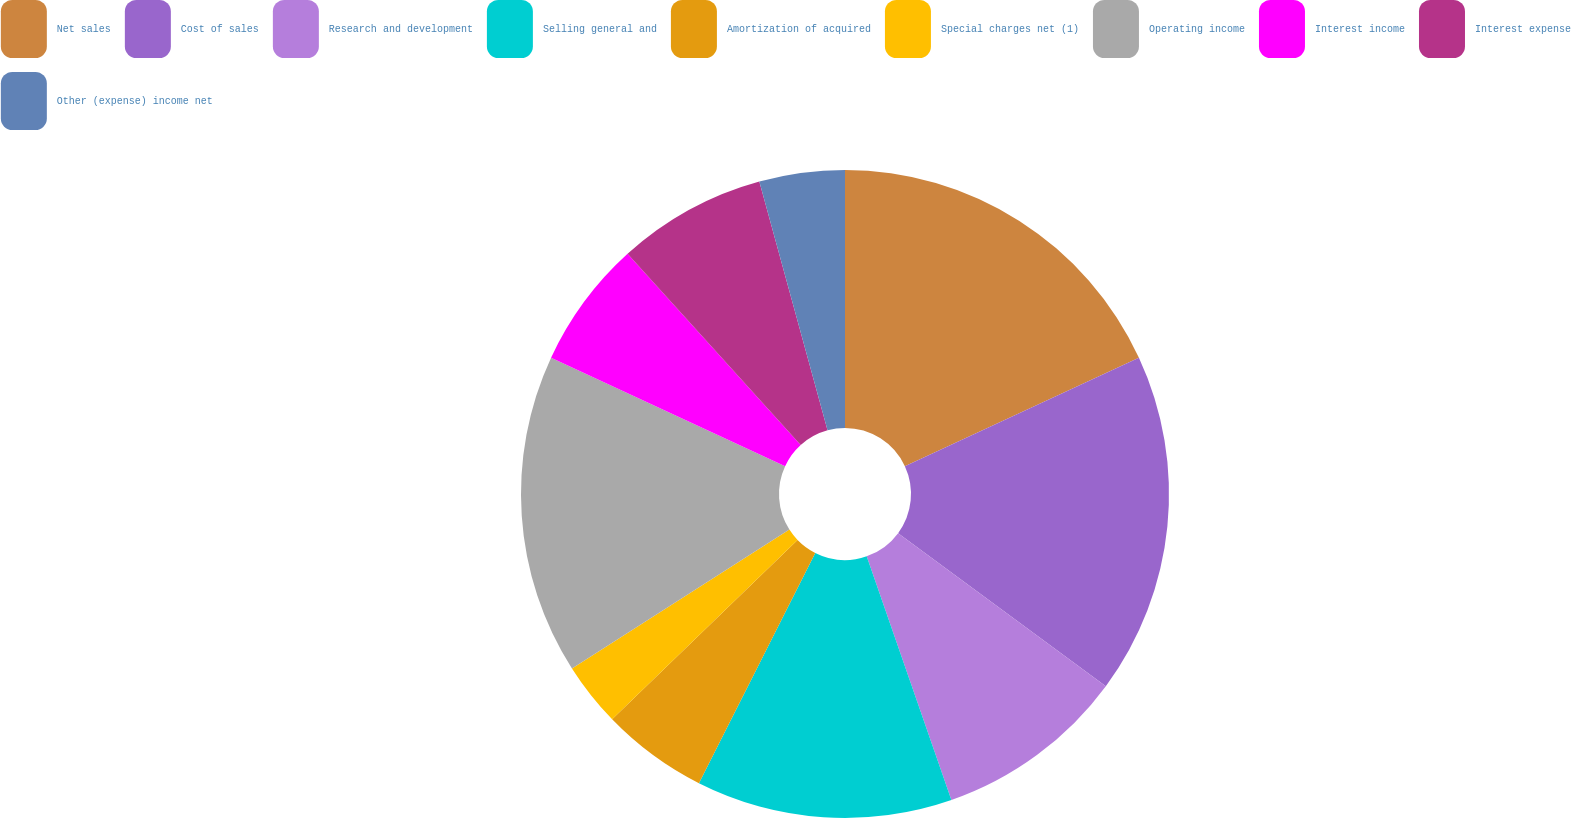Convert chart to OTSL. <chart><loc_0><loc_0><loc_500><loc_500><pie_chart><fcel>Net sales<fcel>Cost of sales<fcel>Research and development<fcel>Selling general and<fcel>Amortization of acquired<fcel>Special charges net (1)<fcel>Operating income<fcel>Interest income<fcel>Interest expense<fcel>Other (expense) income net<nl><fcel>18.09%<fcel>17.02%<fcel>9.57%<fcel>12.77%<fcel>5.32%<fcel>3.19%<fcel>15.96%<fcel>6.38%<fcel>7.45%<fcel>4.26%<nl></chart> 